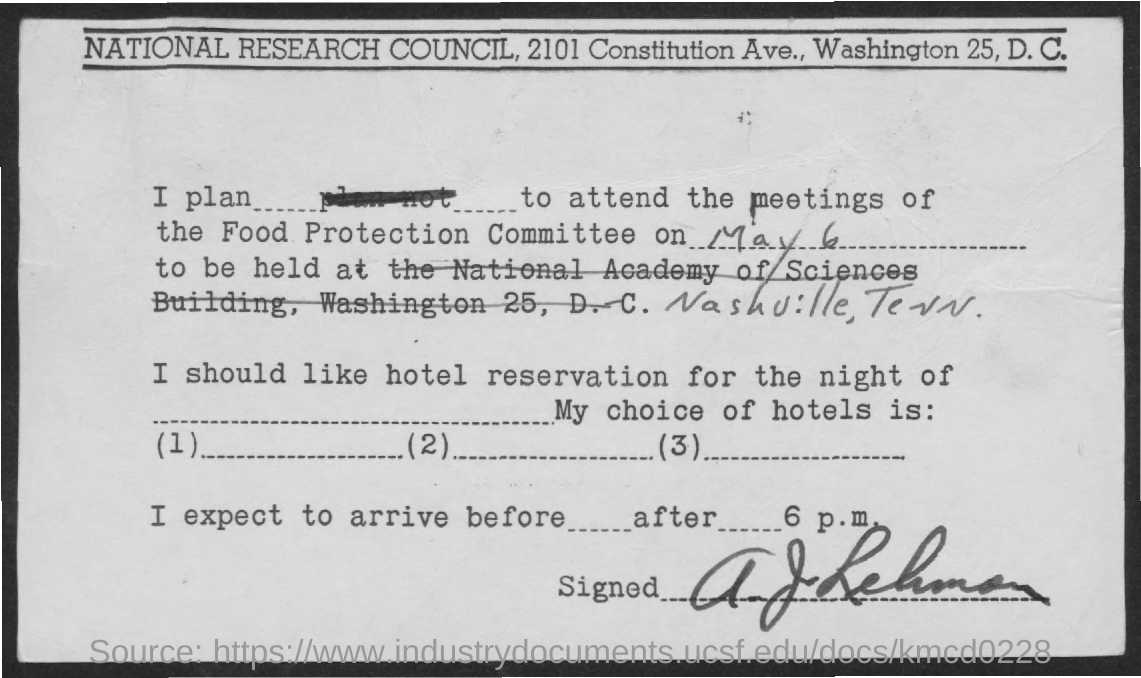When is the meeting of the Food Protection Committee?
Your answer should be very brief. May 6. Where is it to be held at?
Offer a very short reply. Nashville, Tenn. 